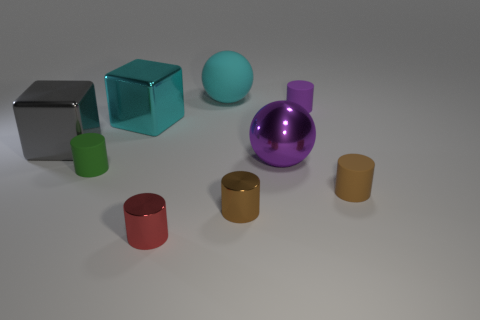Subtract all tiny brown rubber cylinders. How many cylinders are left? 4 Subtract all red cylinders. How many cylinders are left? 4 Subtract all green balls. Subtract all green cylinders. How many balls are left? 2 Subtract all cylinders. How many objects are left? 4 Add 3 metal spheres. How many metal spheres exist? 4 Subtract 0 red balls. How many objects are left? 9 Subtract all small purple matte things. Subtract all small brown metallic cylinders. How many objects are left? 7 Add 6 brown matte cylinders. How many brown matte cylinders are left? 7 